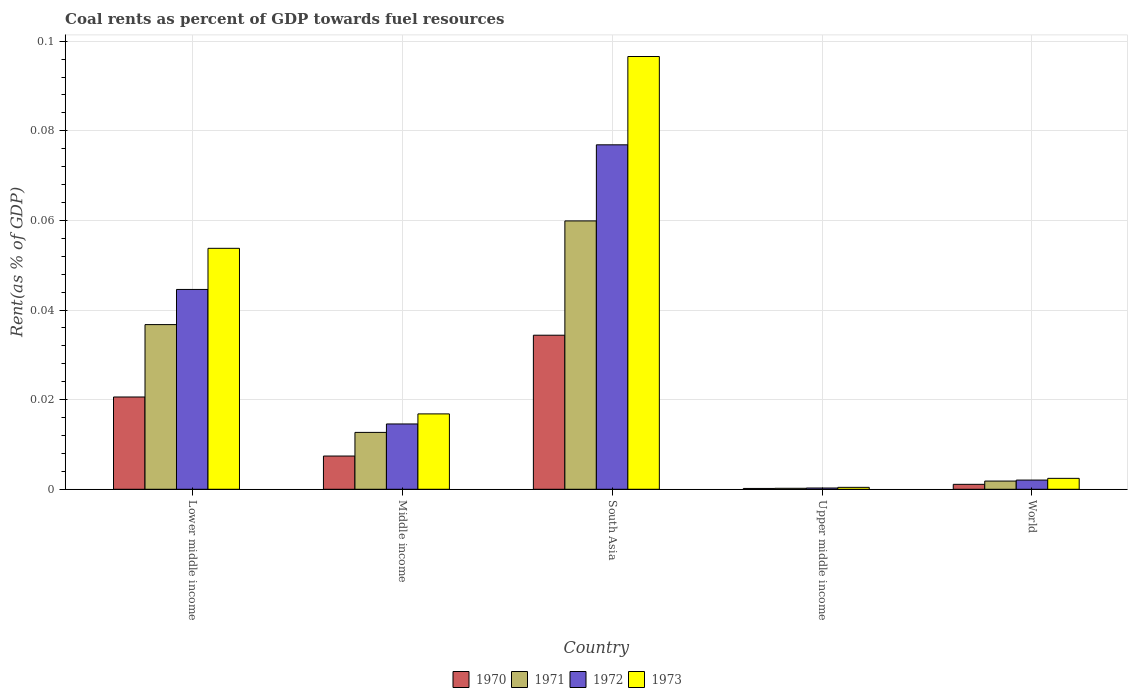How many different coloured bars are there?
Keep it short and to the point. 4. Are the number of bars per tick equal to the number of legend labels?
Offer a very short reply. Yes. Are the number of bars on each tick of the X-axis equal?
Keep it short and to the point. Yes. How many bars are there on the 1st tick from the left?
Provide a succinct answer. 4. How many bars are there on the 5th tick from the right?
Ensure brevity in your answer.  4. What is the label of the 3rd group of bars from the left?
Give a very brief answer. South Asia. What is the coal rent in 1971 in Upper middle income?
Provide a succinct answer. 0. Across all countries, what is the maximum coal rent in 1973?
Offer a very short reply. 0.1. Across all countries, what is the minimum coal rent in 1970?
Provide a short and direct response. 0. In which country was the coal rent in 1972 minimum?
Give a very brief answer. Upper middle income. What is the total coal rent in 1973 in the graph?
Make the answer very short. 0.17. What is the difference between the coal rent in 1972 in South Asia and that in World?
Provide a succinct answer. 0.07. What is the difference between the coal rent in 1971 in Upper middle income and the coal rent in 1973 in South Asia?
Make the answer very short. -0.1. What is the average coal rent in 1973 per country?
Ensure brevity in your answer.  0.03. What is the difference between the coal rent of/in 1973 and coal rent of/in 1970 in Middle income?
Keep it short and to the point. 0.01. What is the ratio of the coal rent in 1972 in Middle income to that in World?
Provide a short and direct response. 7.09. Is the coal rent in 1970 in Upper middle income less than that in World?
Make the answer very short. Yes. What is the difference between the highest and the second highest coal rent in 1970?
Your answer should be very brief. 0.01. What is the difference between the highest and the lowest coal rent in 1973?
Your response must be concise. 0.1. Is it the case that in every country, the sum of the coal rent in 1972 and coal rent in 1971 is greater than the sum of coal rent in 1973 and coal rent in 1970?
Make the answer very short. No. What does the 2nd bar from the left in Upper middle income represents?
Your response must be concise. 1971. Is it the case that in every country, the sum of the coal rent in 1972 and coal rent in 1970 is greater than the coal rent in 1971?
Offer a terse response. Yes. Are all the bars in the graph horizontal?
Keep it short and to the point. No. How many countries are there in the graph?
Your answer should be very brief. 5. What is the difference between two consecutive major ticks on the Y-axis?
Your answer should be compact. 0.02. Does the graph contain any zero values?
Give a very brief answer. No. How many legend labels are there?
Give a very brief answer. 4. What is the title of the graph?
Give a very brief answer. Coal rents as percent of GDP towards fuel resources. Does "2002" appear as one of the legend labels in the graph?
Ensure brevity in your answer.  No. What is the label or title of the X-axis?
Provide a short and direct response. Country. What is the label or title of the Y-axis?
Offer a terse response. Rent(as % of GDP). What is the Rent(as % of GDP) in 1970 in Lower middle income?
Give a very brief answer. 0.02. What is the Rent(as % of GDP) of 1971 in Lower middle income?
Ensure brevity in your answer.  0.04. What is the Rent(as % of GDP) of 1972 in Lower middle income?
Offer a terse response. 0.04. What is the Rent(as % of GDP) in 1973 in Lower middle income?
Your answer should be very brief. 0.05. What is the Rent(as % of GDP) in 1970 in Middle income?
Your response must be concise. 0.01. What is the Rent(as % of GDP) in 1971 in Middle income?
Make the answer very short. 0.01. What is the Rent(as % of GDP) of 1972 in Middle income?
Make the answer very short. 0.01. What is the Rent(as % of GDP) of 1973 in Middle income?
Offer a very short reply. 0.02. What is the Rent(as % of GDP) in 1970 in South Asia?
Provide a short and direct response. 0.03. What is the Rent(as % of GDP) of 1971 in South Asia?
Keep it short and to the point. 0.06. What is the Rent(as % of GDP) of 1972 in South Asia?
Provide a succinct answer. 0.08. What is the Rent(as % of GDP) in 1973 in South Asia?
Your answer should be compact. 0.1. What is the Rent(as % of GDP) of 1970 in Upper middle income?
Offer a very short reply. 0. What is the Rent(as % of GDP) in 1971 in Upper middle income?
Ensure brevity in your answer.  0. What is the Rent(as % of GDP) of 1972 in Upper middle income?
Your answer should be very brief. 0. What is the Rent(as % of GDP) of 1973 in Upper middle income?
Provide a short and direct response. 0. What is the Rent(as % of GDP) of 1970 in World?
Offer a very short reply. 0. What is the Rent(as % of GDP) of 1971 in World?
Give a very brief answer. 0. What is the Rent(as % of GDP) of 1972 in World?
Your answer should be very brief. 0. What is the Rent(as % of GDP) of 1973 in World?
Your answer should be very brief. 0. Across all countries, what is the maximum Rent(as % of GDP) of 1970?
Offer a very short reply. 0.03. Across all countries, what is the maximum Rent(as % of GDP) of 1971?
Offer a very short reply. 0.06. Across all countries, what is the maximum Rent(as % of GDP) of 1972?
Keep it short and to the point. 0.08. Across all countries, what is the maximum Rent(as % of GDP) of 1973?
Offer a very short reply. 0.1. Across all countries, what is the minimum Rent(as % of GDP) in 1970?
Your answer should be very brief. 0. Across all countries, what is the minimum Rent(as % of GDP) in 1971?
Offer a terse response. 0. Across all countries, what is the minimum Rent(as % of GDP) of 1972?
Give a very brief answer. 0. Across all countries, what is the minimum Rent(as % of GDP) in 1973?
Make the answer very short. 0. What is the total Rent(as % of GDP) in 1970 in the graph?
Keep it short and to the point. 0.06. What is the total Rent(as % of GDP) of 1971 in the graph?
Keep it short and to the point. 0.11. What is the total Rent(as % of GDP) in 1972 in the graph?
Offer a terse response. 0.14. What is the total Rent(as % of GDP) of 1973 in the graph?
Give a very brief answer. 0.17. What is the difference between the Rent(as % of GDP) of 1970 in Lower middle income and that in Middle income?
Give a very brief answer. 0.01. What is the difference between the Rent(as % of GDP) of 1971 in Lower middle income and that in Middle income?
Provide a succinct answer. 0.02. What is the difference between the Rent(as % of GDP) in 1973 in Lower middle income and that in Middle income?
Your response must be concise. 0.04. What is the difference between the Rent(as % of GDP) in 1970 in Lower middle income and that in South Asia?
Provide a succinct answer. -0.01. What is the difference between the Rent(as % of GDP) of 1971 in Lower middle income and that in South Asia?
Give a very brief answer. -0.02. What is the difference between the Rent(as % of GDP) of 1972 in Lower middle income and that in South Asia?
Your answer should be compact. -0.03. What is the difference between the Rent(as % of GDP) of 1973 in Lower middle income and that in South Asia?
Provide a succinct answer. -0.04. What is the difference between the Rent(as % of GDP) in 1970 in Lower middle income and that in Upper middle income?
Your response must be concise. 0.02. What is the difference between the Rent(as % of GDP) in 1971 in Lower middle income and that in Upper middle income?
Give a very brief answer. 0.04. What is the difference between the Rent(as % of GDP) of 1972 in Lower middle income and that in Upper middle income?
Ensure brevity in your answer.  0.04. What is the difference between the Rent(as % of GDP) in 1973 in Lower middle income and that in Upper middle income?
Give a very brief answer. 0.05. What is the difference between the Rent(as % of GDP) in 1970 in Lower middle income and that in World?
Provide a succinct answer. 0.02. What is the difference between the Rent(as % of GDP) in 1971 in Lower middle income and that in World?
Your answer should be compact. 0.03. What is the difference between the Rent(as % of GDP) of 1972 in Lower middle income and that in World?
Provide a succinct answer. 0.04. What is the difference between the Rent(as % of GDP) in 1973 in Lower middle income and that in World?
Offer a terse response. 0.05. What is the difference between the Rent(as % of GDP) of 1970 in Middle income and that in South Asia?
Provide a short and direct response. -0.03. What is the difference between the Rent(as % of GDP) of 1971 in Middle income and that in South Asia?
Your answer should be compact. -0.05. What is the difference between the Rent(as % of GDP) of 1972 in Middle income and that in South Asia?
Make the answer very short. -0.06. What is the difference between the Rent(as % of GDP) of 1973 in Middle income and that in South Asia?
Your answer should be very brief. -0.08. What is the difference between the Rent(as % of GDP) of 1970 in Middle income and that in Upper middle income?
Keep it short and to the point. 0.01. What is the difference between the Rent(as % of GDP) in 1971 in Middle income and that in Upper middle income?
Provide a succinct answer. 0.01. What is the difference between the Rent(as % of GDP) of 1972 in Middle income and that in Upper middle income?
Your answer should be very brief. 0.01. What is the difference between the Rent(as % of GDP) in 1973 in Middle income and that in Upper middle income?
Ensure brevity in your answer.  0.02. What is the difference between the Rent(as % of GDP) of 1970 in Middle income and that in World?
Ensure brevity in your answer.  0.01. What is the difference between the Rent(as % of GDP) of 1971 in Middle income and that in World?
Offer a terse response. 0.01. What is the difference between the Rent(as % of GDP) of 1972 in Middle income and that in World?
Make the answer very short. 0.01. What is the difference between the Rent(as % of GDP) of 1973 in Middle income and that in World?
Provide a short and direct response. 0.01. What is the difference between the Rent(as % of GDP) in 1970 in South Asia and that in Upper middle income?
Offer a terse response. 0.03. What is the difference between the Rent(as % of GDP) in 1971 in South Asia and that in Upper middle income?
Make the answer very short. 0.06. What is the difference between the Rent(as % of GDP) of 1972 in South Asia and that in Upper middle income?
Offer a very short reply. 0.08. What is the difference between the Rent(as % of GDP) in 1973 in South Asia and that in Upper middle income?
Ensure brevity in your answer.  0.1. What is the difference between the Rent(as % of GDP) of 1971 in South Asia and that in World?
Make the answer very short. 0.06. What is the difference between the Rent(as % of GDP) of 1972 in South Asia and that in World?
Your answer should be very brief. 0.07. What is the difference between the Rent(as % of GDP) in 1973 in South Asia and that in World?
Provide a short and direct response. 0.09. What is the difference between the Rent(as % of GDP) of 1970 in Upper middle income and that in World?
Ensure brevity in your answer.  -0. What is the difference between the Rent(as % of GDP) in 1971 in Upper middle income and that in World?
Provide a succinct answer. -0. What is the difference between the Rent(as % of GDP) of 1972 in Upper middle income and that in World?
Your answer should be compact. -0. What is the difference between the Rent(as % of GDP) of 1973 in Upper middle income and that in World?
Your answer should be very brief. -0. What is the difference between the Rent(as % of GDP) of 1970 in Lower middle income and the Rent(as % of GDP) of 1971 in Middle income?
Ensure brevity in your answer.  0.01. What is the difference between the Rent(as % of GDP) of 1970 in Lower middle income and the Rent(as % of GDP) of 1972 in Middle income?
Provide a succinct answer. 0.01. What is the difference between the Rent(as % of GDP) of 1970 in Lower middle income and the Rent(as % of GDP) of 1973 in Middle income?
Your response must be concise. 0. What is the difference between the Rent(as % of GDP) of 1971 in Lower middle income and the Rent(as % of GDP) of 1972 in Middle income?
Your response must be concise. 0.02. What is the difference between the Rent(as % of GDP) of 1971 in Lower middle income and the Rent(as % of GDP) of 1973 in Middle income?
Keep it short and to the point. 0.02. What is the difference between the Rent(as % of GDP) of 1972 in Lower middle income and the Rent(as % of GDP) of 1973 in Middle income?
Ensure brevity in your answer.  0.03. What is the difference between the Rent(as % of GDP) in 1970 in Lower middle income and the Rent(as % of GDP) in 1971 in South Asia?
Your response must be concise. -0.04. What is the difference between the Rent(as % of GDP) in 1970 in Lower middle income and the Rent(as % of GDP) in 1972 in South Asia?
Offer a terse response. -0.06. What is the difference between the Rent(as % of GDP) in 1970 in Lower middle income and the Rent(as % of GDP) in 1973 in South Asia?
Provide a succinct answer. -0.08. What is the difference between the Rent(as % of GDP) of 1971 in Lower middle income and the Rent(as % of GDP) of 1972 in South Asia?
Provide a succinct answer. -0.04. What is the difference between the Rent(as % of GDP) in 1971 in Lower middle income and the Rent(as % of GDP) in 1973 in South Asia?
Ensure brevity in your answer.  -0.06. What is the difference between the Rent(as % of GDP) in 1972 in Lower middle income and the Rent(as % of GDP) in 1973 in South Asia?
Keep it short and to the point. -0.05. What is the difference between the Rent(as % of GDP) of 1970 in Lower middle income and the Rent(as % of GDP) of 1971 in Upper middle income?
Your response must be concise. 0.02. What is the difference between the Rent(as % of GDP) in 1970 in Lower middle income and the Rent(as % of GDP) in 1972 in Upper middle income?
Provide a short and direct response. 0.02. What is the difference between the Rent(as % of GDP) of 1970 in Lower middle income and the Rent(as % of GDP) of 1973 in Upper middle income?
Provide a short and direct response. 0.02. What is the difference between the Rent(as % of GDP) of 1971 in Lower middle income and the Rent(as % of GDP) of 1972 in Upper middle income?
Your answer should be very brief. 0.04. What is the difference between the Rent(as % of GDP) in 1971 in Lower middle income and the Rent(as % of GDP) in 1973 in Upper middle income?
Offer a very short reply. 0.04. What is the difference between the Rent(as % of GDP) in 1972 in Lower middle income and the Rent(as % of GDP) in 1973 in Upper middle income?
Offer a very short reply. 0.04. What is the difference between the Rent(as % of GDP) of 1970 in Lower middle income and the Rent(as % of GDP) of 1971 in World?
Give a very brief answer. 0.02. What is the difference between the Rent(as % of GDP) of 1970 in Lower middle income and the Rent(as % of GDP) of 1972 in World?
Ensure brevity in your answer.  0.02. What is the difference between the Rent(as % of GDP) of 1970 in Lower middle income and the Rent(as % of GDP) of 1973 in World?
Your answer should be very brief. 0.02. What is the difference between the Rent(as % of GDP) in 1971 in Lower middle income and the Rent(as % of GDP) in 1972 in World?
Keep it short and to the point. 0.03. What is the difference between the Rent(as % of GDP) of 1971 in Lower middle income and the Rent(as % of GDP) of 1973 in World?
Provide a succinct answer. 0.03. What is the difference between the Rent(as % of GDP) of 1972 in Lower middle income and the Rent(as % of GDP) of 1973 in World?
Give a very brief answer. 0.04. What is the difference between the Rent(as % of GDP) in 1970 in Middle income and the Rent(as % of GDP) in 1971 in South Asia?
Give a very brief answer. -0.05. What is the difference between the Rent(as % of GDP) of 1970 in Middle income and the Rent(as % of GDP) of 1972 in South Asia?
Provide a succinct answer. -0.07. What is the difference between the Rent(as % of GDP) in 1970 in Middle income and the Rent(as % of GDP) in 1973 in South Asia?
Offer a very short reply. -0.09. What is the difference between the Rent(as % of GDP) of 1971 in Middle income and the Rent(as % of GDP) of 1972 in South Asia?
Your answer should be very brief. -0.06. What is the difference between the Rent(as % of GDP) of 1971 in Middle income and the Rent(as % of GDP) of 1973 in South Asia?
Make the answer very short. -0.08. What is the difference between the Rent(as % of GDP) of 1972 in Middle income and the Rent(as % of GDP) of 1973 in South Asia?
Ensure brevity in your answer.  -0.08. What is the difference between the Rent(as % of GDP) in 1970 in Middle income and the Rent(as % of GDP) in 1971 in Upper middle income?
Provide a short and direct response. 0.01. What is the difference between the Rent(as % of GDP) of 1970 in Middle income and the Rent(as % of GDP) of 1972 in Upper middle income?
Provide a succinct answer. 0.01. What is the difference between the Rent(as % of GDP) in 1970 in Middle income and the Rent(as % of GDP) in 1973 in Upper middle income?
Your answer should be very brief. 0.01. What is the difference between the Rent(as % of GDP) of 1971 in Middle income and the Rent(as % of GDP) of 1972 in Upper middle income?
Ensure brevity in your answer.  0.01. What is the difference between the Rent(as % of GDP) in 1971 in Middle income and the Rent(as % of GDP) in 1973 in Upper middle income?
Your answer should be compact. 0.01. What is the difference between the Rent(as % of GDP) in 1972 in Middle income and the Rent(as % of GDP) in 1973 in Upper middle income?
Provide a short and direct response. 0.01. What is the difference between the Rent(as % of GDP) of 1970 in Middle income and the Rent(as % of GDP) of 1971 in World?
Ensure brevity in your answer.  0.01. What is the difference between the Rent(as % of GDP) in 1970 in Middle income and the Rent(as % of GDP) in 1972 in World?
Your response must be concise. 0.01. What is the difference between the Rent(as % of GDP) in 1970 in Middle income and the Rent(as % of GDP) in 1973 in World?
Offer a terse response. 0.01. What is the difference between the Rent(as % of GDP) of 1971 in Middle income and the Rent(as % of GDP) of 1972 in World?
Make the answer very short. 0.01. What is the difference between the Rent(as % of GDP) of 1971 in Middle income and the Rent(as % of GDP) of 1973 in World?
Provide a succinct answer. 0.01. What is the difference between the Rent(as % of GDP) in 1972 in Middle income and the Rent(as % of GDP) in 1973 in World?
Offer a very short reply. 0.01. What is the difference between the Rent(as % of GDP) in 1970 in South Asia and the Rent(as % of GDP) in 1971 in Upper middle income?
Your response must be concise. 0.03. What is the difference between the Rent(as % of GDP) of 1970 in South Asia and the Rent(as % of GDP) of 1972 in Upper middle income?
Provide a succinct answer. 0.03. What is the difference between the Rent(as % of GDP) of 1970 in South Asia and the Rent(as % of GDP) of 1973 in Upper middle income?
Give a very brief answer. 0.03. What is the difference between the Rent(as % of GDP) in 1971 in South Asia and the Rent(as % of GDP) in 1972 in Upper middle income?
Make the answer very short. 0.06. What is the difference between the Rent(as % of GDP) of 1971 in South Asia and the Rent(as % of GDP) of 1973 in Upper middle income?
Offer a very short reply. 0.06. What is the difference between the Rent(as % of GDP) in 1972 in South Asia and the Rent(as % of GDP) in 1973 in Upper middle income?
Your answer should be compact. 0.08. What is the difference between the Rent(as % of GDP) in 1970 in South Asia and the Rent(as % of GDP) in 1971 in World?
Your response must be concise. 0.03. What is the difference between the Rent(as % of GDP) in 1970 in South Asia and the Rent(as % of GDP) in 1972 in World?
Provide a succinct answer. 0.03. What is the difference between the Rent(as % of GDP) in 1970 in South Asia and the Rent(as % of GDP) in 1973 in World?
Your response must be concise. 0.03. What is the difference between the Rent(as % of GDP) of 1971 in South Asia and the Rent(as % of GDP) of 1972 in World?
Ensure brevity in your answer.  0.06. What is the difference between the Rent(as % of GDP) in 1971 in South Asia and the Rent(as % of GDP) in 1973 in World?
Your answer should be very brief. 0.06. What is the difference between the Rent(as % of GDP) of 1972 in South Asia and the Rent(as % of GDP) of 1973 in World?
Offer a terse response. 0.07. What is the difference between the Rent(as % of GDP) of 1970 in Upper middle income and the Rent(as % of GDP) of 1971 in World?
Provide a short and direct response. -0. What is the difference between the Rent(as % of GDP) in 1970 in Upper middle income and the Rent(as % of GDP) in 1972 in World?
Your response must be concise. -0. What is the difference between the Rent(as % of GDP) of 1970 in Upper middle income and the Rent(as % of GDP) of 1973 in World?
Your response must be concise. -0. What is the difference between the Rent(as % of GDP) of 1971 in Upper middle income and the Rent(as % of GDP) of 1972 in World?
Give a very brief answer. -0. What is the difference between the Rent(as % of GDP) of 1971 in Upper middle income and the Rent(as % of GDP) of 1973 in World?
Your response must be concise. -0. What is the difference between the Rent(as % of GDP) of 1972 in Upper middle income and the Rent(as % of GDP) of 1973 in World?
Offer a terse response. -0. What is the average Rent(as % of GDP) in 1970 per country?
Provide a short and direct response. 0.01. What is the average Rent(as % of GDP) of 1971 per country?
Offer a terse response. 0.02. What is the average Rent(as % of GDP) of 1972 per country?
Offer a terse response. 0.03. What is the average Rent(as % of GDP) of 1973 per country?
Provide a short and direct response. 0.03. What is the difference between the Rent(as % of GDP) of 1970 and Rent(as % of GDP) of 1971 in Lower middle income?
Provide a succinct answer. -0.02. What is the difference between the Rent(as % of GDP) of 1970 and Rent(as % of GDP) of 1972 in Lower middle income?
Offer a terse response. -0.02. What is the difference between the Rent(as % of GDP) in 1970 and Rent(as % of GDP) in 1973 in Lower middle income?
Your response must be concise. -0.03. What is the difference between the Rent(as % of GDP) in 1971 and Rent(as % of GDP) in 1972 in Lower middle income?
Offer a terse response. -0.01. What is the difference between the Rent(as % of GDP) in 1971 and Rent(as % of GDP) in 1973 in Lower middle income?
Your answer should be compact. -0.02. What is the difference between the Rent(as % of GDP) in 1972 and Rent(as % of GDP) in 1973 in Lower middle income?
Make the answer very short. -0.01. What is the difference between the Rent(as % of GDP) of 1970 and Rent(as % of GDP) of 1971 in Middle income?
Ensure brevity in your answer.  -0.01. What is the difference between the Rent(as % of GDP) of 1970 and Rent(as % of GDP) of 1972 in Middle income?
Give a very brief answer. -0.01. What is the difference between the Rent(as % of GDP) in 1970 and Rent(as % of GDP) in 1973 in Middle income?
Your answer should be compact. -0.01. What is the difference between the Rent(as % of GDP) in 1971 and Rent(as % of GDP) in 1972 in Middle income?
Offer a terse response. -0. What is the difference between the Rent(as % of GDP) in 1971 and Rent(as % of GDP) in 1973 in Middle income?
Give a very brief answer. -0. What is the difference between the Rent(as % of GDP) in 1972 and Rent(as % of GDP) in 1973 in Middle income?
Ensure brevity in your answer.  -0. What is the difference between the Rent(as % of GDP) of 1970 and Rent(as % of GDP) of 1971 in South Asia?
Make the answer very short. -0.03. What is the difference between the Rent(as % of GDP) in 1970 and Rent(as % of GDP) in 1972 in South Asia?
Provide a succinct answer. -0.04. What is the difference between the Rent(as % of GDP) of 1970 and Rent(as % of GDP) of 1973 in South Asia?
Your answer should be very brief. -0.06. What is the difference between the Rent(as % of GDP) in 1971 and Rent(as % of GDP) in 1972 in South Asia?
Provide a short and direct response. -0.02. What is the difference between the Rent(as % of GDP) in 1971 and Rent(as % of GDP) in 1973 in South Asia?
Make the answer very short. -0.04. What is the difference between the Rent(as % of GDP) in 1972 and Rent(as % of GDP) in 1973 in South Asia?
Your answer should be compact. -0.02. What is the difference between the Rent(as % of GDP) in 1970 and Rent(as % of GDP) in 1972 in Upper middle income?
Offer a terse response. -0. What is the difference between the Rent(as % of GDP) in 1970 and Rent(as % of GDP) in 1973 in Upper middle income?
Offer a terse response. -0. What is the difference between the Rent(as % of GDP) in 1971 and Rent(as % of GDP) in 1972 in Upper middle income?
Provide a short and direct response. -0. What is the difference between the Rent(as % of GDP) in 1971 and Rent(as % of GDP) in 1973 in Upper middle income?
Provide a succinct answer. -0. What is the difference between the Rent(as % of GDP) in 1972 and Rent(as % of GDP) in 1973 in Upper middle income?
Give a very brief answer. -0. What is the difference between the Rent(as % of GDP) of 1970 and Rent(as % of GDP) of 1971 in World?
Give a very brief answer. -0. What is the difference between the Rent(as % of GDP) of 1970 and Rent(as % of GDP) of 1972 in World?
Provide a short and direct response. -0. What is the difference between the Rent(as % of GDP) of 1970 and Rent(as % of GDP) of 1973 in World?
Your answer should be compact. -0. What is the difference between the Rent(as % of GDP) in 1971 and Rent(as % of GDP) in 1972 in World?
Your response must be concise. -0. What is the difference between the Rent(as % of GDP) in 1971 and Rent(as % of GDP) in 1973 in World?
Provide a succinct answer. -0. What is the difference between the Rent(as % of GDP) in 1972 and Rent(as % of GDP) in 1973 in World?
Keep it short and to the point. -0. What is the ratio of the Rent(as % of GDP) in 1970 in Lower middle income to that in Middle income?
Give a very brief answer. 2.78. What is the ratio of the Rent(as % of GDP) in 1971 in Lower middle income to that in Middle income?
Give a very brief answer. 2.9. What is the ratio of the Rent(as % of GDP) of 1972 in Lower middle income to that in Middle income?
Ensure brevity in your answer.  3.06. What is the ratio of the Rent(as % of GDP) in 1973 in Lower middle income to that in Middle income?
Ensure brevity in your answer.  3.2. What is the ratio of the Rent(as % of GDP) of 1970 in Lower middle income to that in South Asia?
Provide a succinct answer. 0.6. What is the ratio of the Rent(as % of GDP) of 1971 in Lower middle income to that in South Asia?
Ensure brevity in your answer.  0.61. What is the ratio of the Rent(as % of GDP) in 1972 in Lower middle income to that in South Asia?
Keep it short and to the point. 0.58. What is the ratio of the Rent(as % of GDP) of 1973 in Lower middle income to that in South Asia?
Provide a short and direct response. 0.56. What is the ratio of the Rent(as % of GDP) of 1970 in Lower middle income to that in Upper middle income?
Give a very brief answer. 112.03. What is the ratio of the Rent(as % of GDP) of 1971 in Lower middle income to that in Upper middle income?
Offer a very short reply. 167.98. What is the ratio of the Rent(as % of GDP) of 1972 in Lower middle income to that in Upper middle income?
Your answer should be compact. 156.82. What is the ratio of the Rent(as % of GDP) in 1973 in Lower middle income to that in Upper middle income?
Make the answer very short. 124.82. What is the ratio of the Rent(as % of GDP) of 1970 in Lower middle income to that in World?
Make the answer very short. 18.71. What is the ratio of the Rent(as % of GDP) in 1971 in Lower middle income to that in World?
Offer a terse response. 20.06. What is the ratio of the Rent(as % of GDP) in 1972 in Lower middle income to that in World?
Your answer should be very brief. 21.7. What is the ratio of the Rent(as % of GDP) of 1973 in Lower middle income to that in World?
Ensure brevity in your answer.  22.07. What is the ratio of the Rent(as % of GDP) of 1970 in Middle income to that in South Asia?
Offer a very short reply. 0.22. What is the ratio of the Rent(as % of GDP) of 1971 in Middle income to that in South Asia?
Keep it short and to the point. 0.21. What is the ratio of the Rent(as % of GDP) in 1972 in Middle income to that in South Asia?
Keep it short and to the point. 0.19. What is the ratio of the Rent(as % of GDP) in 1973 in Middle income to that in South Asia?
Provide a short and direct response. 0.17. What is the ratio of the Rent(as % of GDP) of 1970 in Middle income to that in Upper middle income?
Ensure brevity in your answer.  40.36. What is the ratio of the Rent(as % of GDP) of 1971 in Middle income to that in Upper middle income?
Offer a very short reply. 58.01. What is the ratio of the Rent(as % of GDP) in 1972 in Middle income to that in Upper middle income?
Make the answer very short. 51.25. What is the ratio of the Rent(as % of GDP) of 1973 in Middle income to that in Upper middle income?
Provide a succinct answer. 39.04. What is the ratio of the Rent(as % of GDP) in 1970 in Middle income to that in World?
Keep it short and to the point. 6.74. What is the ratio of the Rent(as % of GDP) of 1971 in Middle income to that in World?
Provide a short and direct response. 6.93. What is the ratio of the Rent(as % of GDP) in 1972 in Middle income to that in World?
Make the answer very short. 7.09. What is the ratio of the Rent(as % of GDP) of 1973 in Middle income to that in World?
Provide a short and direct response. 6.91. What is the ratio of the Rent(as % of GDP) of 1970 in South Asia to that in Upper middle income?
Provide a short and direct response. 187.05. What is the ratio of the Rent(as % of GDP) of 1971 in South Asia to that in Upper middle income?
Your answer should be very brief. 273.74. What is the ratio of the Rent(as % of GDP) of 1972 in South Asia to that in Upper middle income?
Your answer should be very brief. 270.32. What is the ratio of the Rent(as % of GDP) in 1973 in South Asia to that in Upper middle income?
Your answer should be very brief. 224.18. What is the ratio of the Rent(as % of GDP) in 1970 in South Asia to that in World?
Offer a very short reply. 31.24. What is the ratio of the Rent(as % of GDP) in 1971 in South Asia to that in World?
Offer a terse response. 32.69. What is the ratio of the Rent(as % of GDP) in 1972 in South Asia to that in World?
Your answer should be very brief. 37.41. What is the ratio of the Rent(as % of GDP) of 1973 in South Asia to that in World?
Ensure brevity in your answer.  39.65. What is the ratio of the Rent(as % of GDP) in 1970 in Upper middle income to that in World?
Ensure brevity in your answer.  0.17. What is the ratio of the Rent(as % of GDP) of 1971 in Upper middle income to that in World?
Offer a terse response. 0.12. What is the ratio of the Rent(as % of GDP) of 1972 in Upper middle income to that in World?
Your response must be concise. 0.14. What is the ratio of the Rent(as % of GDP) in 1973 in Upper middle income to that in World?
Keep it short and to the point. 0.18. What is the difference between the highest and the second highest Rent(as % of GDP) in 1970?
Offer a very short reply. 0.01. What is the difference between the highest and the second highest Rent(as % of GDP) in 1971?
Provide a short and direct response. 0.02. What is the difference between the highest and the second highest Rent(as % of GDP) of 1972?
Make the answer very short. 0.03. What is the difference between the highest and the second highest Rent(as % of GDP) in 1973?
Make the answer very short. 0.04. What is the difference between the highest and the lowest Rent(as % of GDP) of 1970?
Provide a succinct answer. 0.03. What is the difference between the highest and the lowest Rent(as % of GDP) in 1971?
Keep it short and to the point. 0.06. What is the difference between the highest and the lowest Rent(as % of GDP) in 1972?
Offer a terse response. 0.08. What is the difference between the highest and the lowest Rent(as % of GDP) of 1973?
Offer a very short reply. 0.1. 